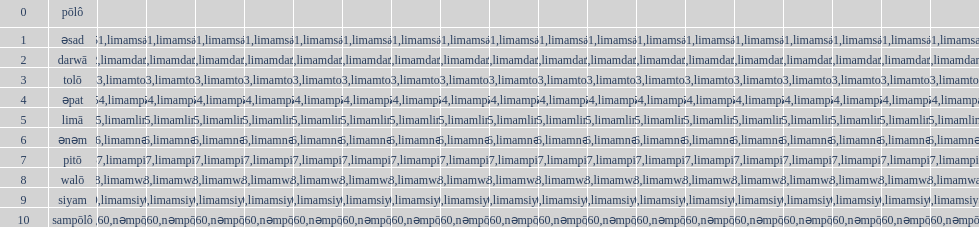In the rinconada bikol language, what is the last single digit integer? Siyam. 